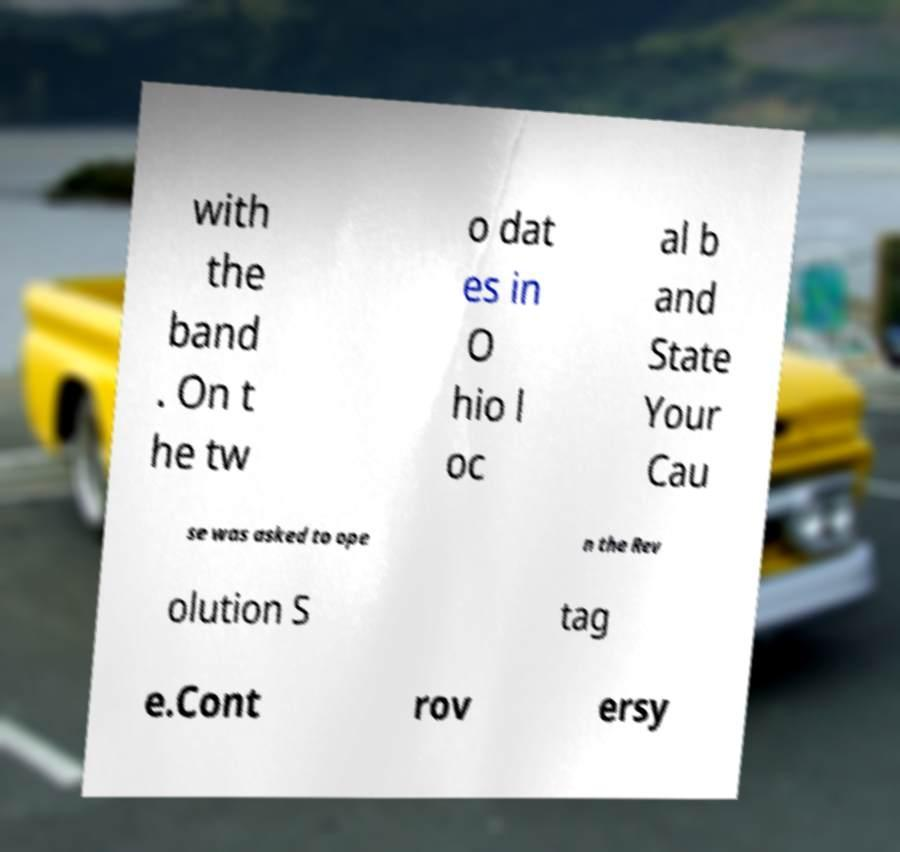For documentation purposes, I need the text within this image transcribed. Could you provide that? with the band . On t he tw o dat es in O hio l oc al b and State Your Cau se was asked to ope n the Rev olution S tag e.Cont rov ersy 